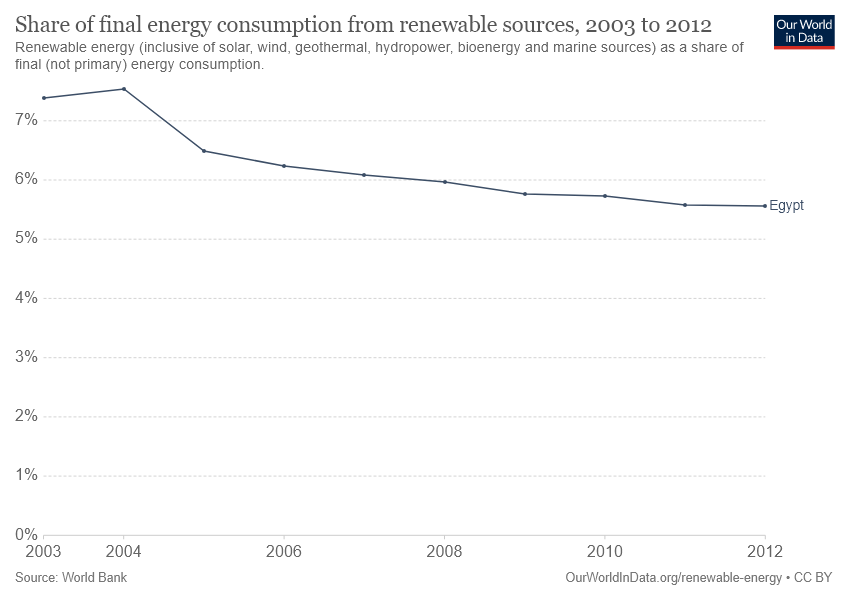Point out several critical features in this image. Between the years 2003 and 2012, the percentage of final energy consumption from renewable sources in Egypt was less than 6% for 4 out of 9 years. In 2008, only 0.06% of Egypt's final energy consumption came from renewable sources. 